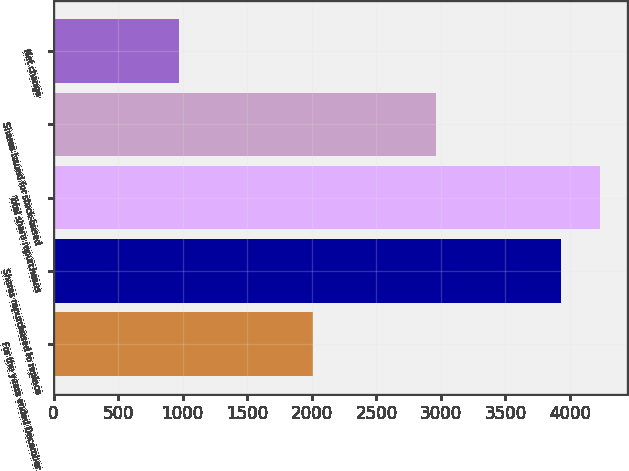Convert chart. <chart><loc_0><loc_0><loc_500><loc_500><bar_chart><fcel>For the years ended December<fcel>Shares repurchased to replace<fcel>Total share repurchases<fcel>Shares issued for stock-based<fcel>Net change<nl><fcel>2010<fcel>3932<fcel>4228.4<fcel>2964<fcel>968<nl></chart> 